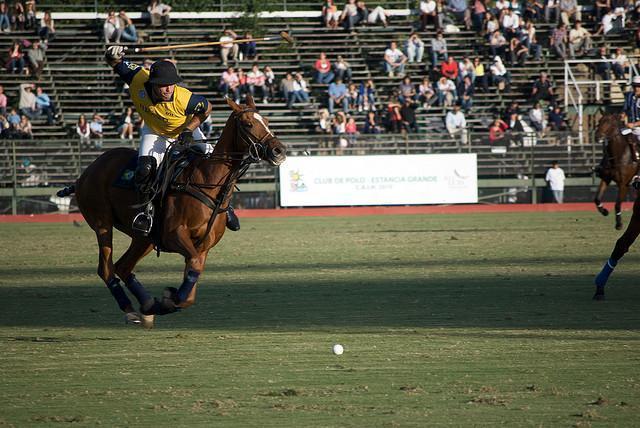How many people can be seen?
Give a very brief answer. 2. How many horses are visible?
Give a very brief answer. 2. 